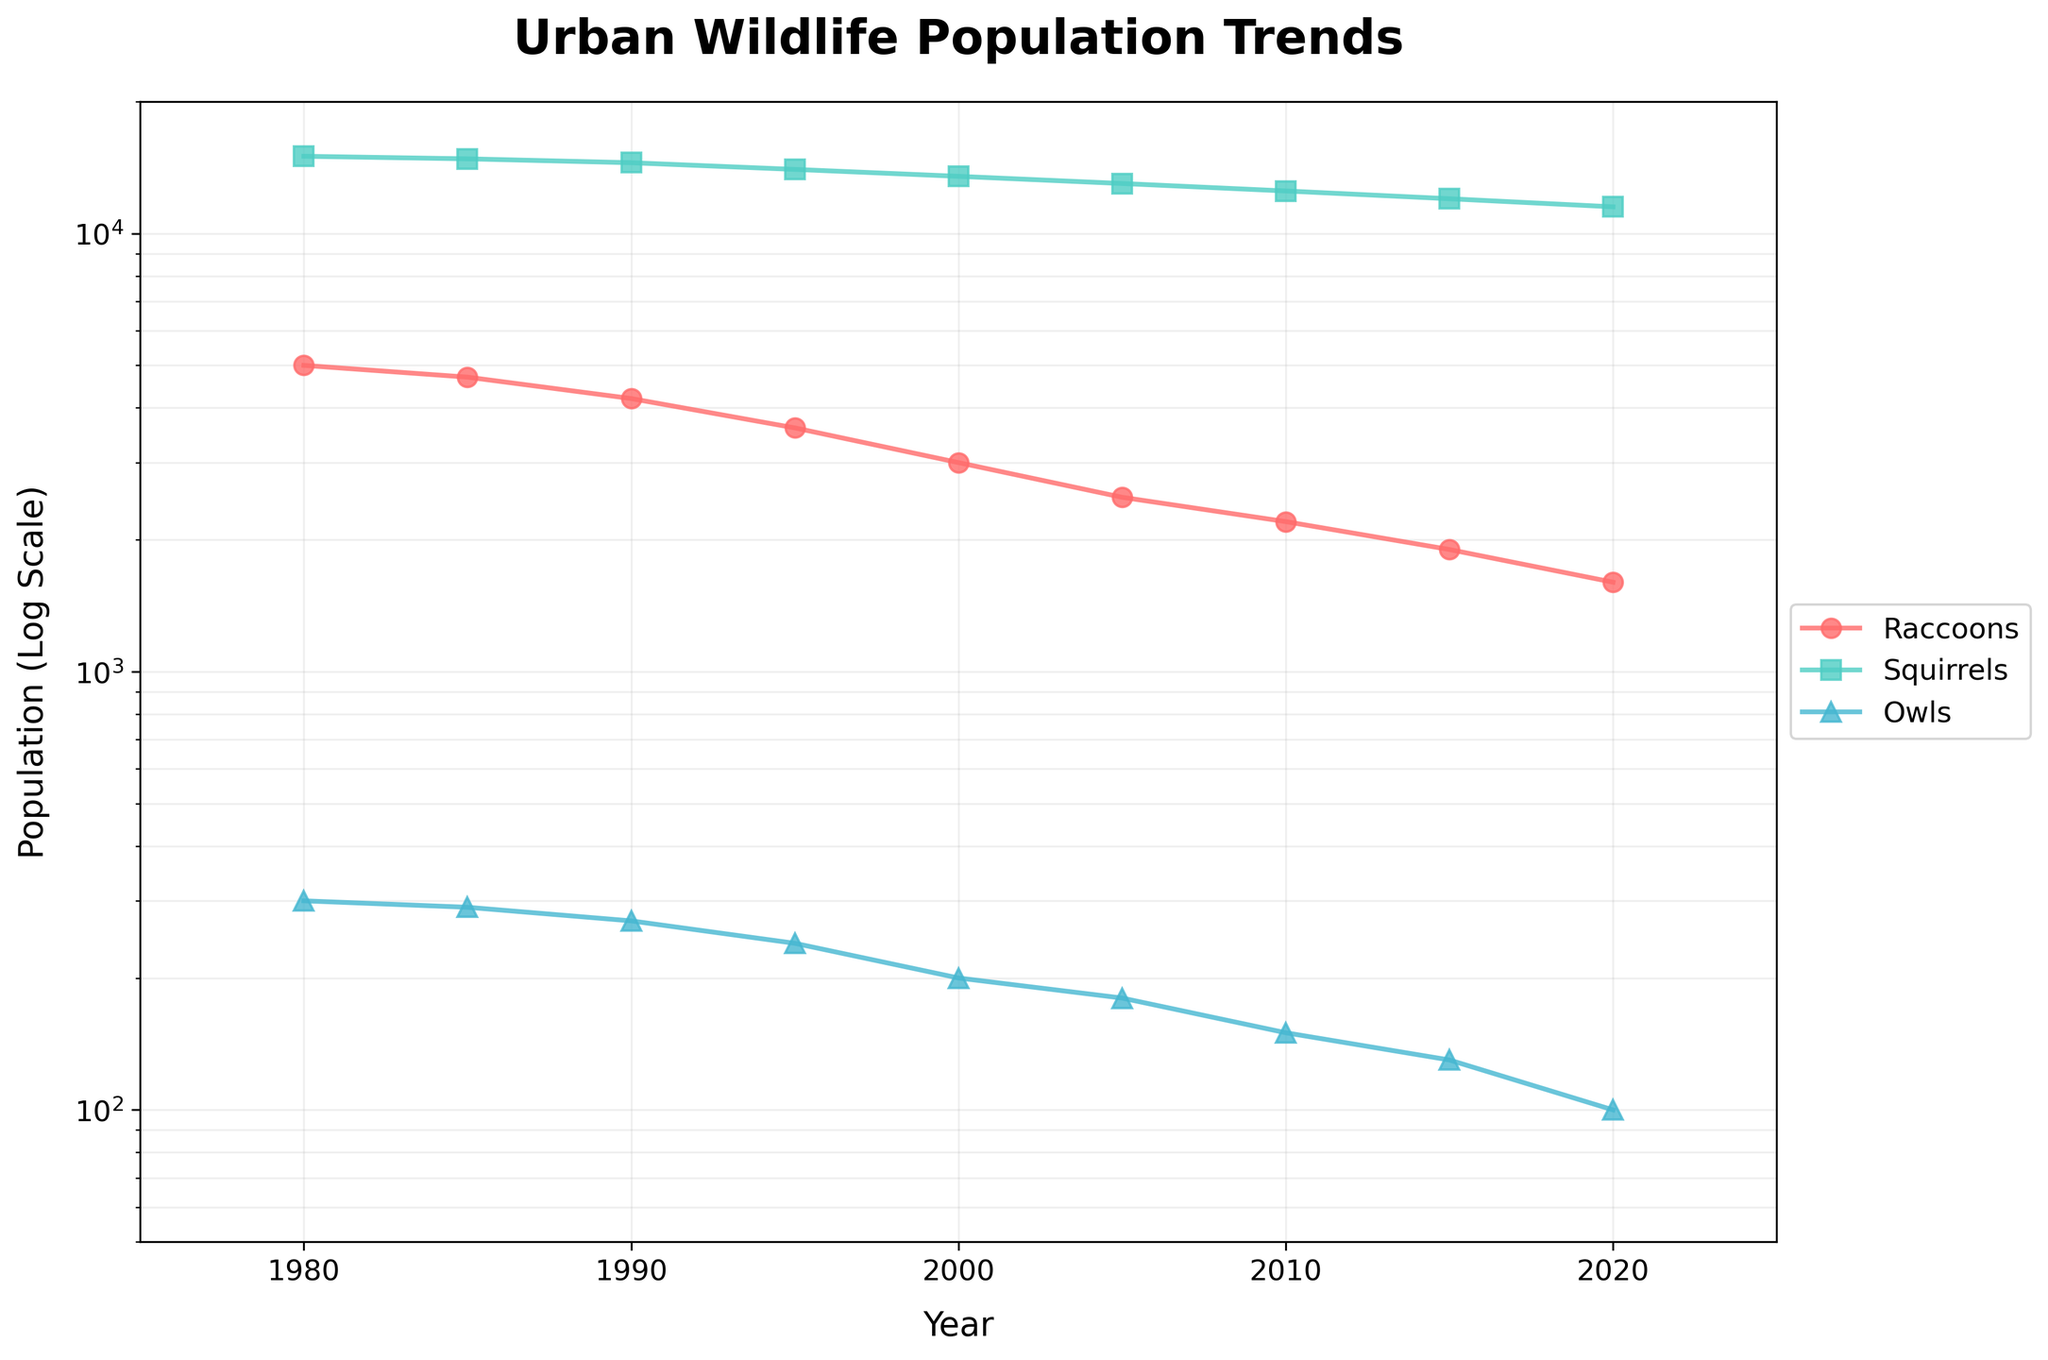What is the title of the figure? The title of the figure is displayed at the top of the plot.
Answer: Urban Wildlife Population Trends What species is represented by the yellow-colored line? The color yellow in the figure represents one of the species shown.
Answer: Raccoons How does the population trend of raccoons differ from that of squirrels? To compare the trends, observe how each line changes over time. The raccoons' population sharply decreases, while the squirrels' population gradually declines.
Answer: Raccoons population sharply decreases; squirrels population gradually declines Between which years did the population of owls experience the most significant decline? By observing the slope of the owl's line, identify the period where the line drops steepest. The steepest decline happens between 2000 and 2020.
Answer: 2000 to 2020 What is the population of squirrels in Golden Gate Park in the year 2005? Locate the year 2005 on the X-axis and trace up to the corresponding point on the squirrels' line.
Answer: 13000 Which species had the smallest population in 2020? Look at 2020 on the X-axis and compare the final points of each line. Owls have the smallest population.
Answer: Owls On average, what is the population change per decade for raccoons? Calculate the population change for each decade, sum them up, and divide by the number of decades. Between 1980-1990 (5000-4200), 1990-2000 (4200-3000), 2000-2010 (3000-2200), 2010-2020 (2200-1600). Sum = -800 - 1000 - 800 - 600 = -3200. Average = -3200/4 = -800 per decade.
Answer: -800 per decade Which species shows the most stable population trend over the period? Determine the species with the least variation in population. The line for squirrels is the flattest, indicating the most stable population trend.
Answer: Squirrels What is the rate of decline in the owl population between 1980 and 2020? Calculate the percentage decline: ((300 - 100) / 300) * 100 = 66.67%
Answer: 66.67% Does the log scale affect the perception of the population decline for any species? Yes, on a log scale, differences at lower ranges appear similar in magnitude to those at higher ranges. Observe the declining trends.
Answer: Yes 